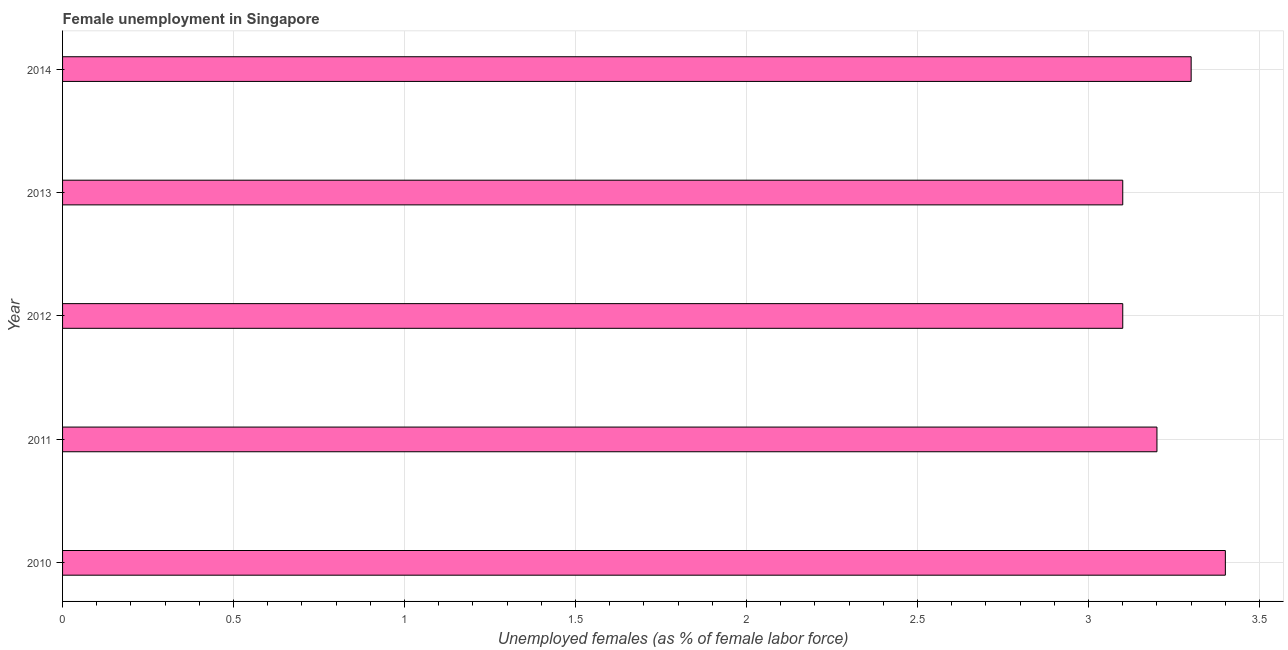Does the graph contain grids?
Offer a very short reply. Yes. What is the title of the graph?
Your response must be concise. Female unemployment in Singapore. What is the label or title of the X-axis?
Make the answer very short. Unemployed females (as % of female labor force). What is the label or title of the Y-axis?
Provide a short and direct response. Year. What is the unemployed females population in 2010?
Offer a terse response. 3.4. Across all years, what is the maximum unemployed females population?
Ensure brevity in your answer.  3.4. Across all years, what is the minimum unemployed females population?
Your answer should be very brief. 3.1. In which year was the unemployed females population maximum?
Offer a terse response. 2010. In which year was the unemployed females population minimum?
Provide a short and direct response. 2012. What is the sum of the unemployed females population?
Provide a short and direct response. 16.1. What is the difference between the unemployed females population in 2011 and 2014?
Provide a short and direct response. -0.1. What is the average unemployed females population per year?
Make the answer very short. 3.22. What is the median unemployed females population?
Keep it short and to the point. 3.2. What is the ratio of the unemployed females population in 2010 to that in 2014?
Offer a terse response. 1.03. What is the difference between the highest and the second highest unemployed females population?
Offer a very short reply. 0.1. Is the sum of the unemployed females population in 2011 and 2012 greater than the maximum unemployed females population across all years?
Your answer should be very brief. Yes. In how many years, is the unemployed females population greater than the average unemployed females population taken over all years?
Make the answer very short. 2. How many bars are there?
Your answer should be very brief. 5. Are all the bars in the graph horizontal?
Your answer should be compact. Yes. Are the values on the major ticks of X-axis written in scientific E-notation?
Offer a terse response. No. What is the Unemployed females (as % of female labor force) in 2010?
Offer a terse response. 3.4. What is the Unemployed females (as % of female labor force) of 2011?
Offer a very short reply. 3.2. What is the Unemployed females (as % of female labor force) of 2012?
Your answer should be compact. 3.1. What is the Unemployed females (as % of female labor force) of 2013?
Keep it short and to the point. 3.1. What is the Unemployed females (as % of female labor force) in 2014?
Provide a succinct answer. 3.3. What is the difference between the Unemployed females (as % of female labor force) in 2010 and 2012?
Your answer should be compact. 0.3. What is the difference between the Unemployed females (as % of female labor force) in 2010 and 2013?
Provide a short and direct response. 0.3. What is the difference between the Unemployed females (as % of female labor force) in 2012 and 2013?
Offer a very short reply. 0. What is the difference between the Unemployed females (as % of female labor force) in 2013 and 2014?
Your answer should be very brief. -0.2. What is the ratio of the Unemployed females (as % of female labor force) in 2010 to that in 2011?
Your answer should be compact. 1.06. What is the ratio of the Unemployed females (as % of female labor force) in 2010 to that in 2012?
Offer a very short reply. 1.1. What is the ratio of the Unemployed females (as % of female labor force) in 2010 to that in 2013?
Provide a short and direct response. 1.1. What is the ratio of the Unemployed females (as % of female labor force) in 2011 to that in 2012?
Your answer should be compact. 1.03. What is the ratio of the Unemployed females (as % of female labor force) in 2011 to that in 2013?
Keep it short and to the point. 1.03. What is the ratio of the Unemployed females (as % of female labor force) in 2012 to that in 2014?
Provide a succinct answer. 0.94. What is the ratio of the Unemployed females (as % of female labor force) in 2013 to that in 2014?
Offer a very short reply. 0.94. 